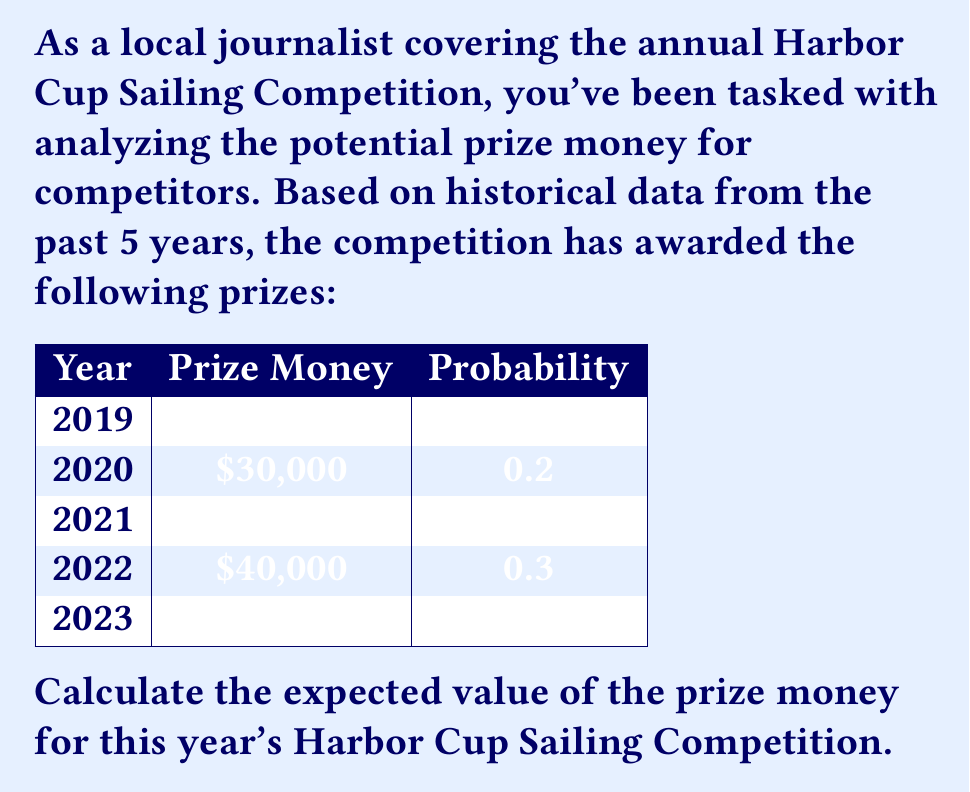Teach me how to tackle this problem. To calculate the expected value of the prize money, we need to follow these steps:

1) The expected value is calculated by multiplying each possible outcome by its probability and then summing these products.

2) Let's calculate this for each year:

   2019: $25,000 \times 0.1 = \$2,500$
   2020: $30,000 \times 0.2 = \$6,000$
   2021: $35,000 \times 0.3 = \$10,500$
   2022: $40,000 \times 0.3 = \$12,000$
   2023: $50,000 \times 0.1 = \$5,000$

3) Now, we sum these values:

   $\$2,500 + \$6,000 + \$10,500 + \$12,000 + \$5,000 = \$36,000$

Therefore, the expected value of the prize money for this year's Harbor Cup Sailing Competition is $\$36,000$.

This calculation can be expressed mathematically as:

$$E(X) = \sum_{i=1}^{n} x_i \cdot p_i$$

Where $x_i$ is each possible prize amount and $p_i$ is its corresponding probability.
Answer: $\$36,000$ 